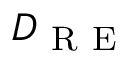Convert formula to latex. <formula><loc_0><loc_0><loc_500><loc_500>D _ { R E }</formula> 